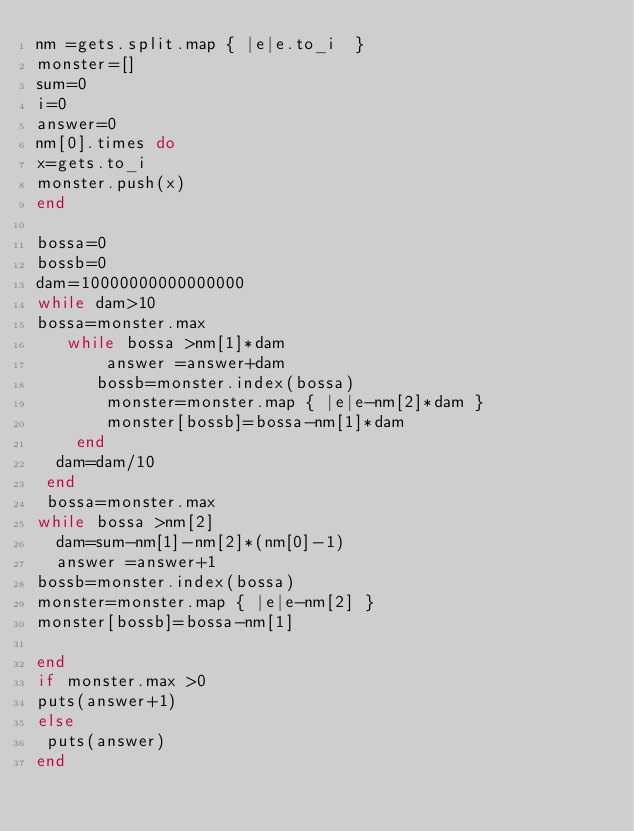<code> <loc_0><loc_0><loc_500><loc_500><_Ruby_>nm =gets.split.map { |e|e.to_i  }
monster=[]
sum=0
i=0
answer=0
nm[0].times do
x=gets.to_i
monster.push(x)
end

bossa=0
bossb=0
dam=10000000000000000
while dam>10
bossa=monster.max
   while bossa >nm[1]*dam
       answer =answer+dam
      bossb=monster.index(bossa)
       monster=monster.map { |e|e-nm[2]*dam }
       monster[bossb]=bossa-nm[1]*dam
    end
  dam=dam/10
 end
 bossa=monster.max
while bossa >nm[2]
  dam=sum-nm[1]-nm[2]*(nm[0]-1)
  answer =answer+1
bossb=monster.index(bossa)
monster=monster.map { |e|e-nm[2] }
monster[bossb]=bossa-nm[1]

end
if monster.max >0
puts(answer+1)
else
 puts(answer)
end
</code> 